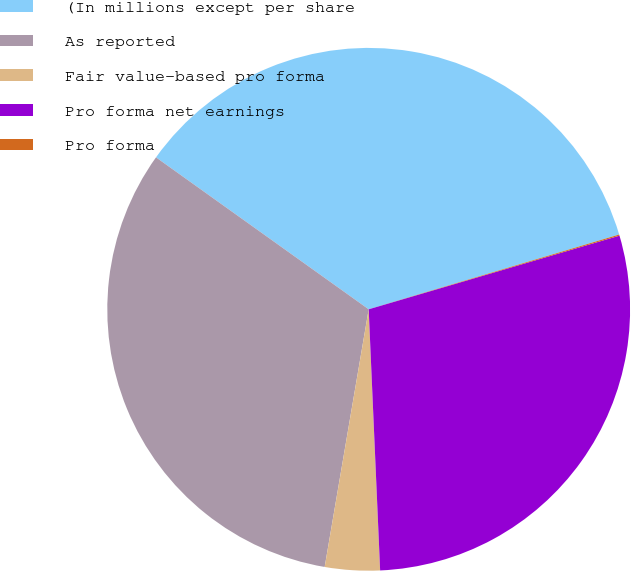Convert chart. <chart><loc_0><loc_0><loc_500><loc_500><pie_chart><fcel>(In millions except per share<fcel>As reported<fcel>Fair value-based pro forma<fcel>Pro forma net earnings<fcel>Pro forma<nl><fcel>35.51%<fcel>32.18%<fcel>3.39%<fcel>28.85%<fcel>0.07%<nl></chart> 